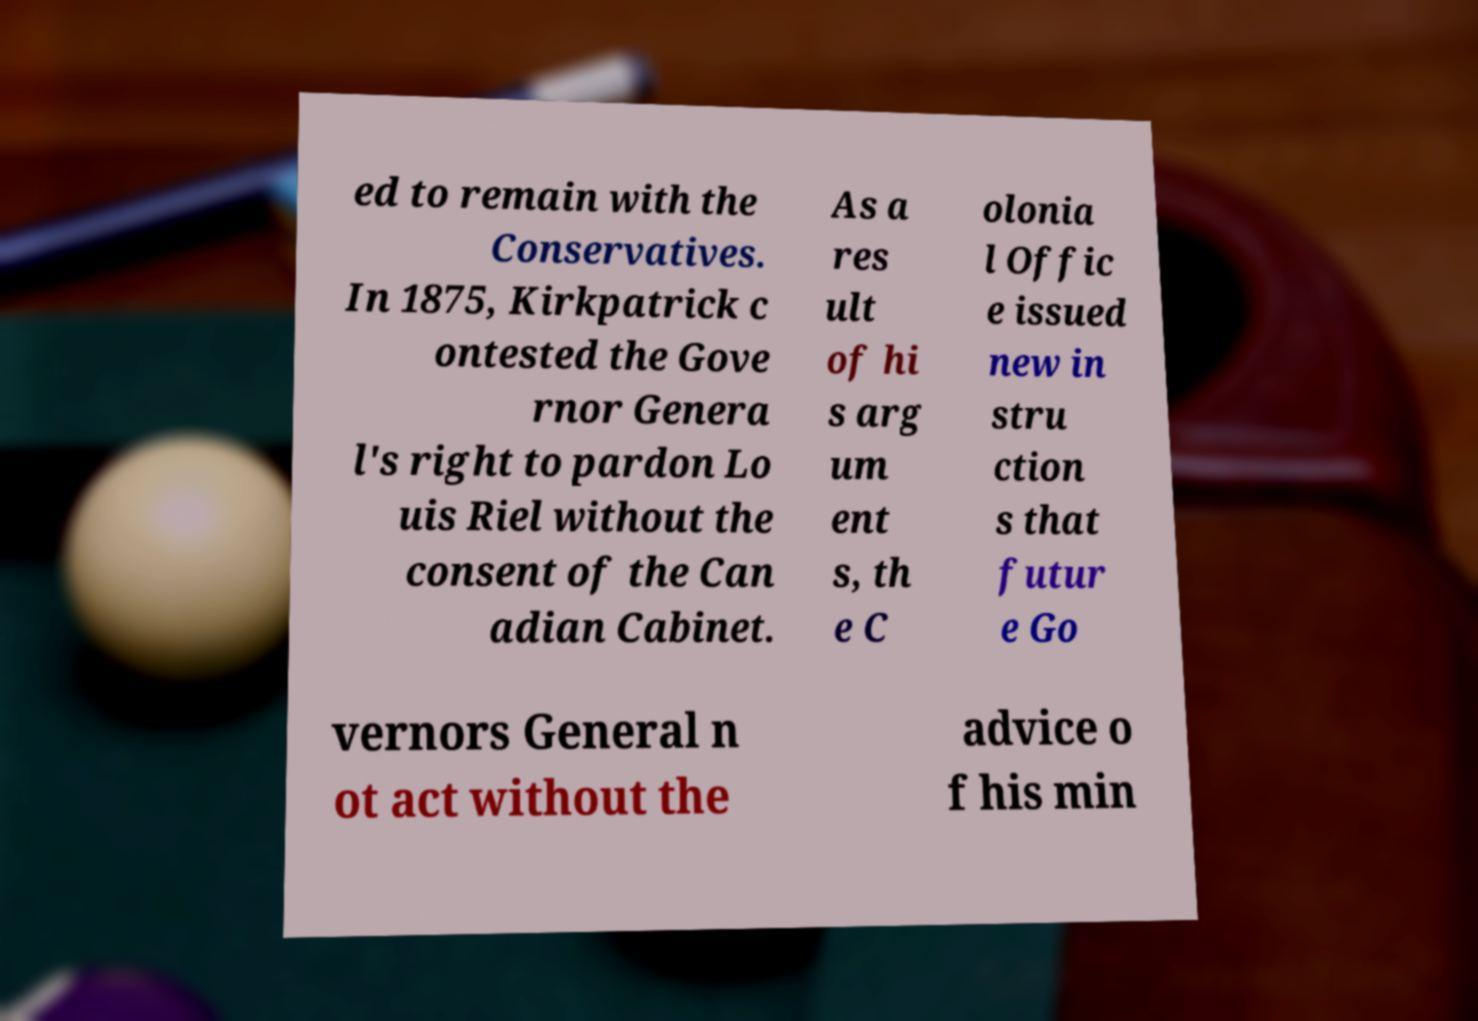Please read and relay the text visible in this image. What does it say? ed to remain with the Conservatives. In 1875, Kirkpatrick c ontested the Gove rnor Genera l's right to pardon Lo uis Riel without the consent of the Can adian Cabinet. As a res ult of hi s arg um ent s, th e C olonia l Offic e issued new in stru ction s that futur e Go vernors General n ot act without the advice o f his min 